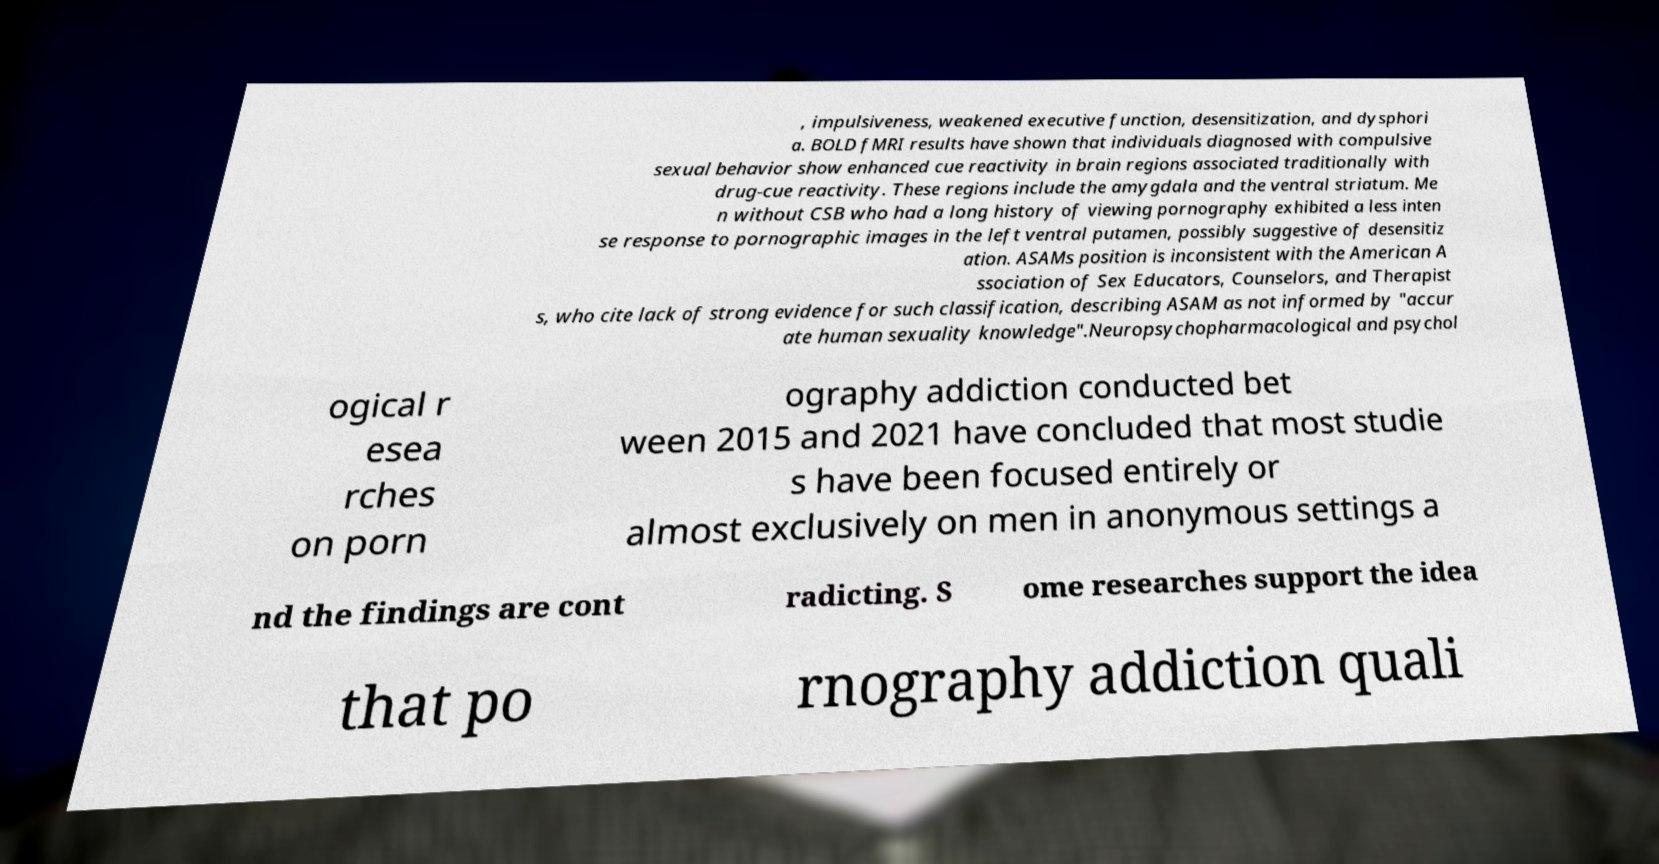Could you assist in decoding the text presented in this image and type it out clearly? , impulsiveness, weakened executive function, desensitization, and dysphori a. BOLD fMRI results have shown that individuals diagnosed with compulsive sexual behavior show enhanced cue reactivity in brain regions associated traditionally with drug-cue reactivity. These regions include the amygdala and the ventral striatum. Me n without CSB who had a long history of viewing pornography exhibited a less inten se response to pornographic images in the left ventral putamen, possibly suggestive of desensitiz ation. ASAMs position is inconsistent with the American A ssociation of Sex Educators, Counselors, and Therapist s, who cite lack of strong evidence for such classification, describing ASAM as not informed by "accur ate human sexuality knowledge".Neuropsychopharmacological and psychol ogical r esea rches on porn ography addiction conducted bet ween 2015 and 2021 have concluded that most studie s have been focused entirely or almost exclusively on men in anonymous settings a nd the findings are cont radicting. S ome researches support the idea that po rnography addiction quali 